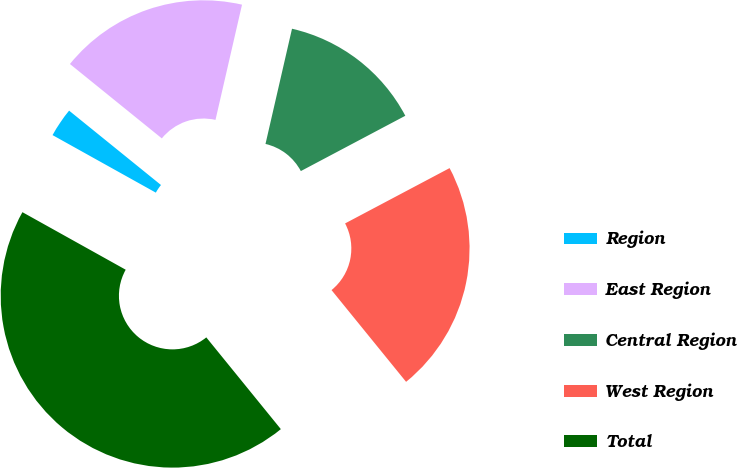<chart> <loc_0><loc_0><loc_500><loc_500><pie_chart><fcel>Region<fcel>East Region<fcel>Central Region<fcel>West Region<fcel>Total<nl><fcel>2.74%<fcel>17.77%<fcel>13.65%<fcel>21.89%<fcel>43.95%<nl></chart> 